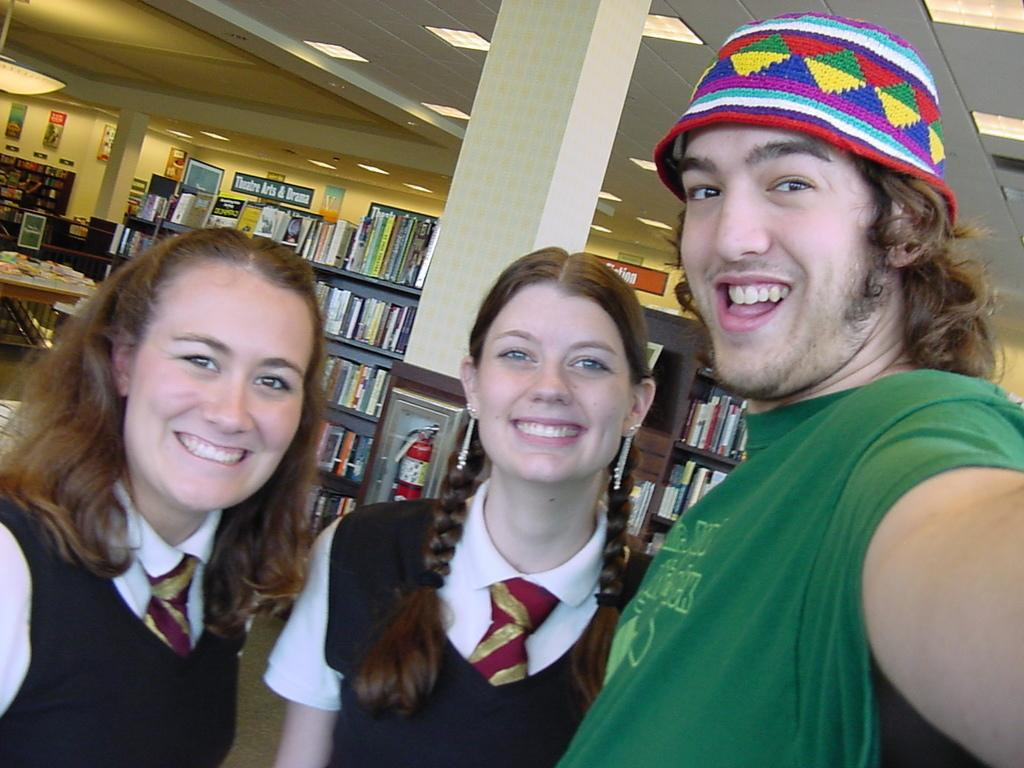Who is present in the image? There is a man and two students in the image. What are the man and students doing? The man and students are taking a selfie. Where does the image appear to be set? The setting appears to be a library. What can be seen in the background of the image? There are shelves with books in the background. What type of knot is the man using to tie his bread in the image? There is no knot or bread present in the image. How many basketballs can be seen in the image? There are no basketballs present in the image. 